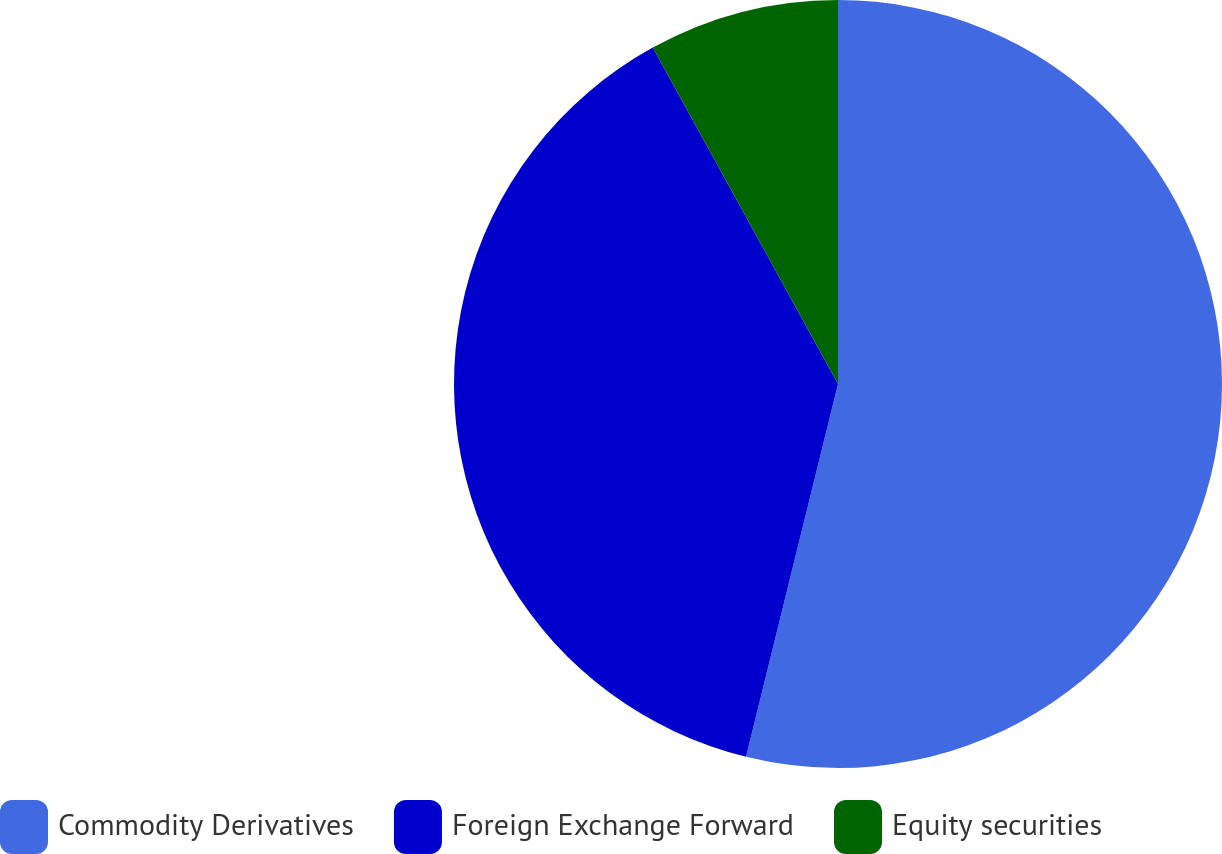<chart> <loc_0><loc_0><loc_500><loc_500><pie_chart><fcel>Commodity Derivatives<fcel>Foreign Exchange Forward<fcel>Equity securities<nl><fcel>53.85%<fcel>38.14%<fcel>8.01%<nl></chart> 